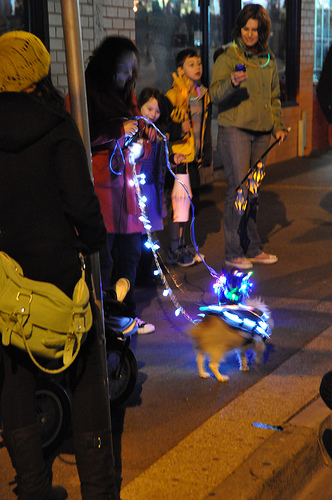<image>
Can you confirm if the lights is on the dog? Yes. Looking at the image, I can see the lights is positioned on top of the dog, with the dog providing support. Is there a lights next to the dog? Yes. The lights is positioned adjacent to the dog, located nearby in the same general area. 